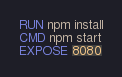<code> <loc_0><loc_0><loc_500><loc_500><_Dockerfile_>RUN npm install
CMD npm start
EXPOSE 8080
</code> 